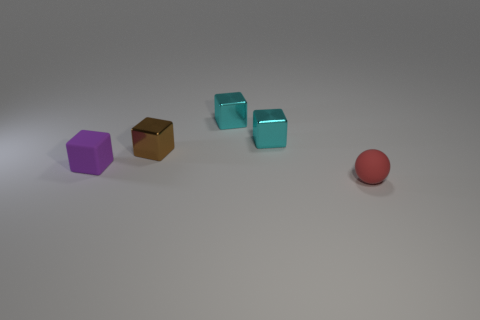Subtract all purple matte cubes. How many cubes are left? 3 Subtract all yellow balls. How many cyan cubes are left? 2 Add 4 purple rubber cubes. How many objects exist? 9 Subtract all cyan blocks. How many blocks are left? 2 Subtract all gray cubes. Subtract all blue cylinders. How many cubes are left? 4 Subtract all balls. How many objects are left? 4 Add 4 matte blocks. How many matte blocks exist? 5 Subtract 0 cyan cylinders. How many objects are left? 5 Subtract all tiny metal things. Subtract all small brown blocks. How many objects are left? 1 Add 4 tiny rubber spheres. How many tiny rubber spheres are left? 5 